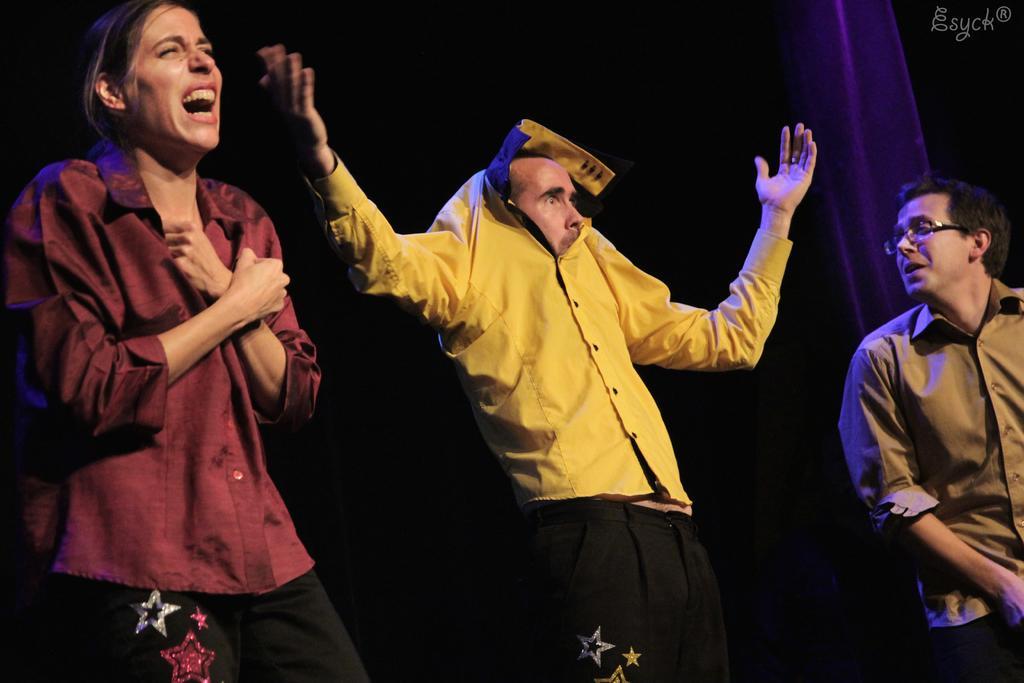How would you summarize this image in a sentence or two? There are three people in the image first, second and third. On the left side there is a women she was laughing and she was wearing a red color shirt. In the middle there is a man he was wearing yellow color shirt and the man on the right side is looking at the middle person. 